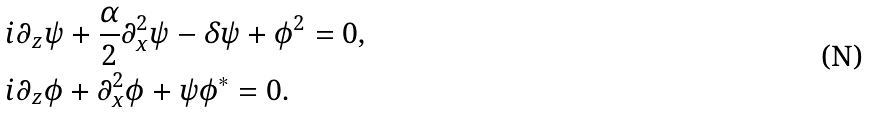Convert formula to latex. <formula><loc_0><loc_0><loc_500><loc_500>& i \partial _ { z } \psi + \frac { \alpha } { 2 } \partial _ { x } ^ { 2 } \psi - \delta \psi + \phi ^ { 2 } = 0 , \\ & i \partial _ { z } \phi + \partial _ { x } ^ { 2 } \phi + \psi \phi ^ { * } = 0 .</formula> 